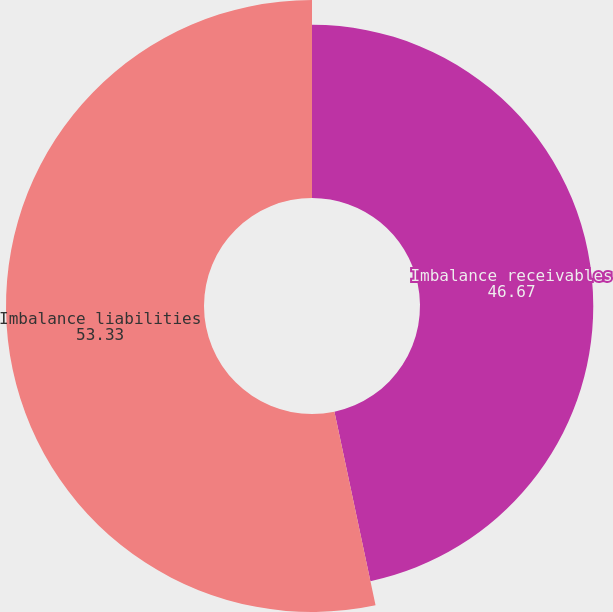Convert chart to OTSL. <chart><loc_0><loc_0><loc_500><loc_500><pie_chart><fcel>Imbalance receivables<fcel>Imbalance liabilities<nl><fcel>46.67%<fcel>53.33%<nl></chart> 